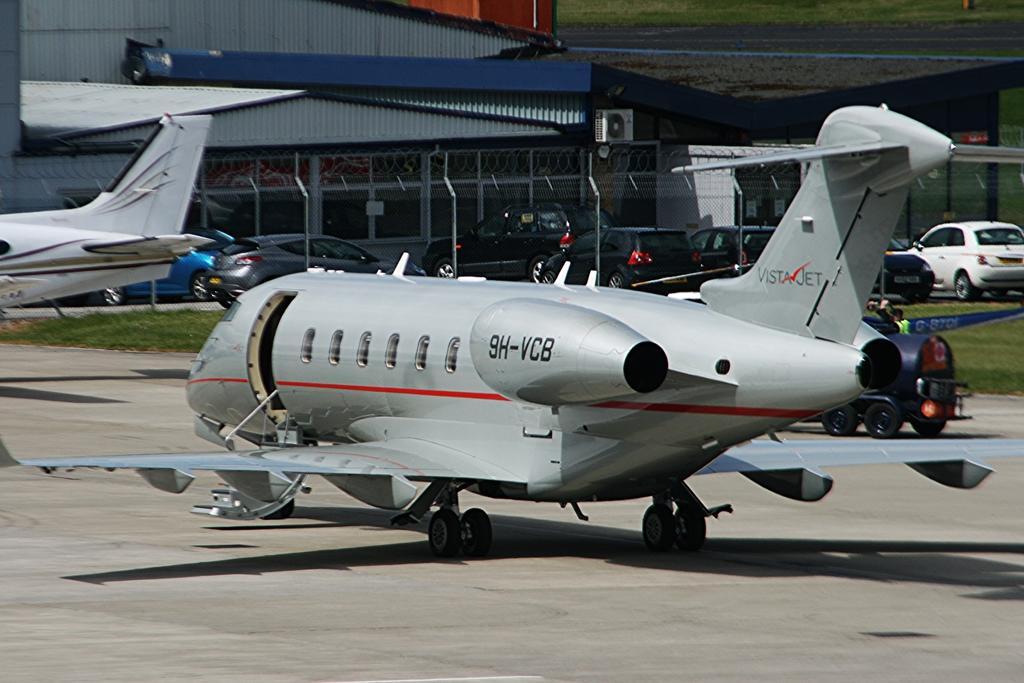Describe this image in one or two sentences. In this image we can see two air crafts, there are vehicles, there is a person on a vehicle, there is a building, an air conditioner, also we can see the grass. 